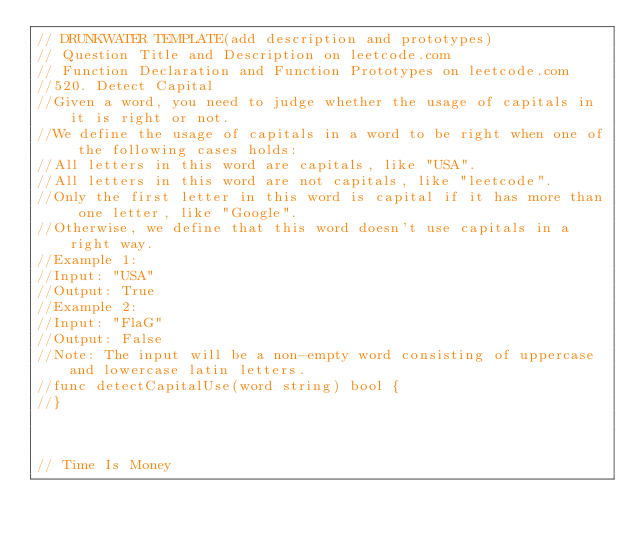<code> <loc_0><loc_0><loc_500><loc_500><_Go_>// DRUNKWATER TEMPLATE(add description and prototypes)
// Question Title and Description on leetcode.com
// Function Declaration and Function Prototypes on leetcode.com
//520. Detect Capital
//Given a word, you need to judge whether the usage of capitals in it is right or not.
//We define the usage of capitals in a word to be right when one of the following cases holds:
//All letters in this word are capitals, like "USA".
//All letters in this word are not capitals, like "leetcode".
//Only the first letter in this word is capital if it has more than one letter, like "Google".
//Otherwise, we define that this word doesn't use capitals in a right way.
//Example 1:
//Input: "USA"
//Output: True
//Example 2:
//Input: "FlaG"
//Output: False
//Note: The input will be a non-empty word consisting of uppercase and lowercase latin letters.
//func detectCapitalUse(word string) bool {
//}



// Time Is Money</code> 